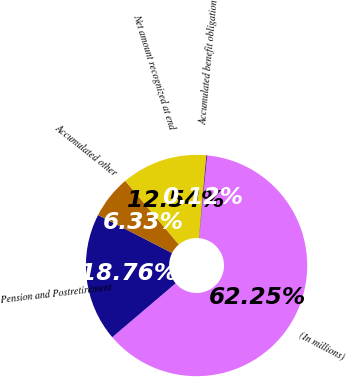<chart> <loc_0><loc_0><loc_500><loc_500><pie_chart><fcel>(In millions)<fcel>Pension and Postretirement<fcel>Accumulated other<fcel>Net amount recognized at end<fcel>Accumulated benefit obligation<nl><fcel>62.25%<fcel>18.76%<fcel>6.33%<fcel>12.54%<fcel>0.12%<nl></chart> 